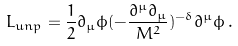Convert formula to latex. <formula><loc_0><loc_0><loc_500><loc_500>L _ { u n p } = \frac { 1 } { 2 } \partial _ { \mu } \phi ( - \frac { \partial ^ { \mu } \partial _ { \mu } } { M ^ { 2 } } ) ^ { - \delta } \partial ^ { \mu } \phi \, .</formula> 